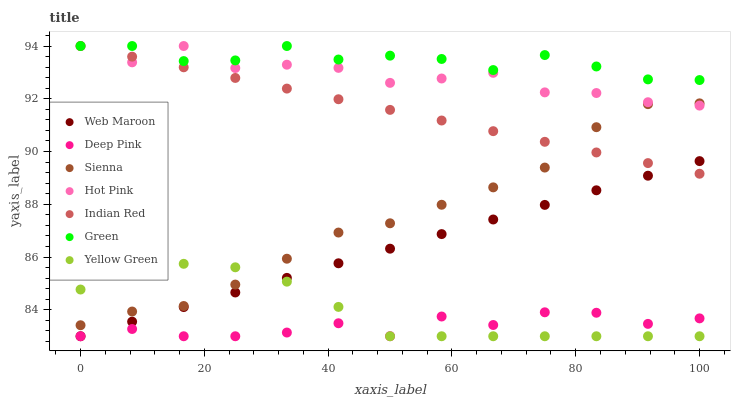Does Deep Pink have the minimum area under the curve?
Answer yes or no. Yes. Does Green have the maximum area under the curve?
Answer yes or no. Yes. Does Yellow Green have the minimum area under the curve?
Answer yes or no. No. Does Yellow Green have the maximum area under the curve?
Answer yes or no. No. Is Indian Red the smoothest?
Answer yes or no. Yes. Is Hot Pink the roughest?
Answer yes or no. Yes. Is Yellow Green the smoothest?
Answer yes or no. No. Is Yellow Green the roughest?
Answer yes or no. No. Does Deep Pink have the lowest value?
Answer yes or no. Yes. Does Hot Pink have the lowest value?
Answer yes or no. No. Does Indian Red have the highest value?
Answer yes or no. Yes. Does Yellow Green have the highest value?
Answer yes or no. No. Is Web Maroon less than Hot Pink?
Answer yes or no. Yes. Is Hot Pink greater than Deep Pink?
Answer yes or no. Yes. Does Web Maroon intersect Indian Red?
Answer yes or no. Yes. Is Web Maroon less than Indian Red?
Answer yes or no. No. Is Web Maroon greater than Indian Red?
Answer yes or no. No. Does Web Maroon intersect Hot Pink?
Answer yes or no. No. 